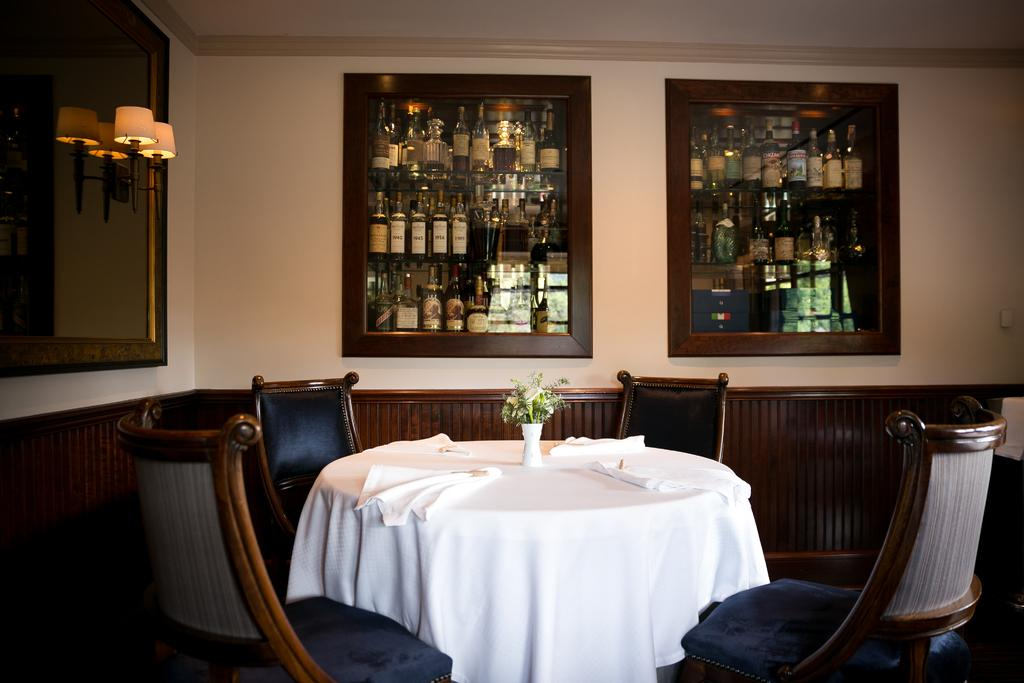What type of furniture is present in the image? There are chairs and a table in the image. What is placed on the table? Clothes and a flower vase are present on the table. What can be seen in the background of the image? There is a wall, lights, and glass cupboards with bottles in the background of the image. What type of ornament is the farmer holding in the image? There is no farmer or ornament present in the image. What hobbies are the people in the image engaged in? The image does not show any people or their hobbies. 